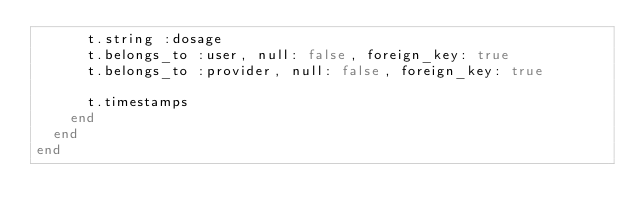Convert code to text. <code><loc_0><loc_0><loc_500><loc_500><_Ruby_>      t.string :dosage
      t.belongs_to :user, null: false, foreign_key: true
      t.belongs_to :provider, null: false, foreign_key: true

      t.timestamps
    end
  end
end
</code> 